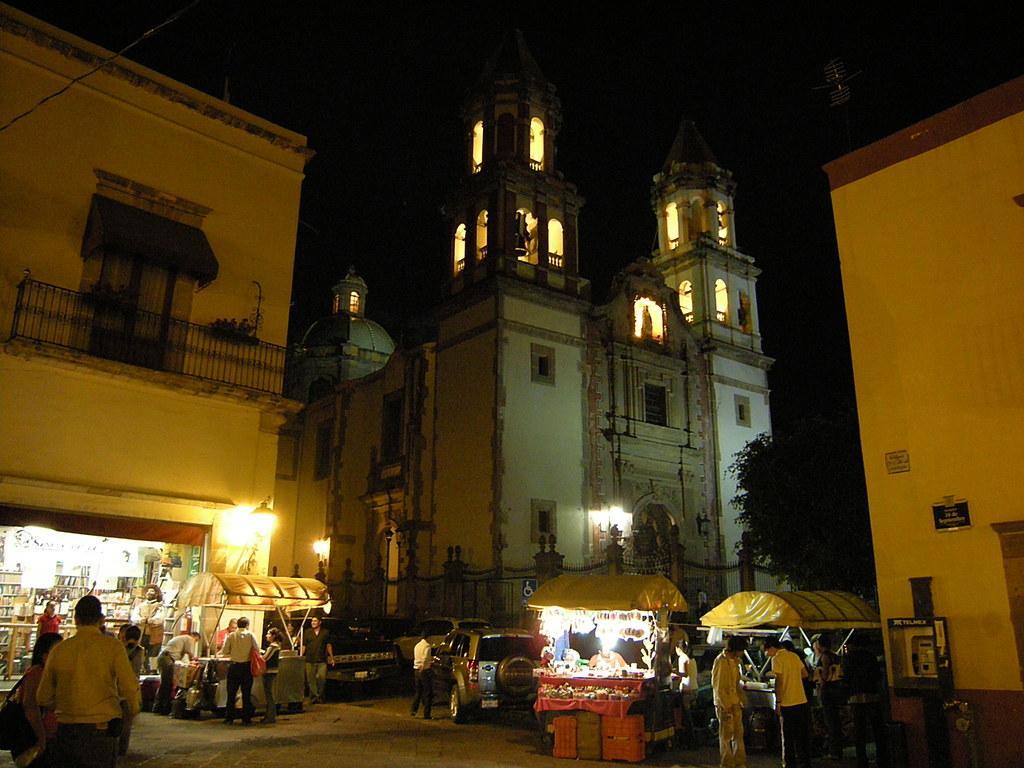How would you summarize this image in a sentence or two? In this image in the center there are vehicles, there are persons standing and in the background there are buildings and there is a tree on the right side. 